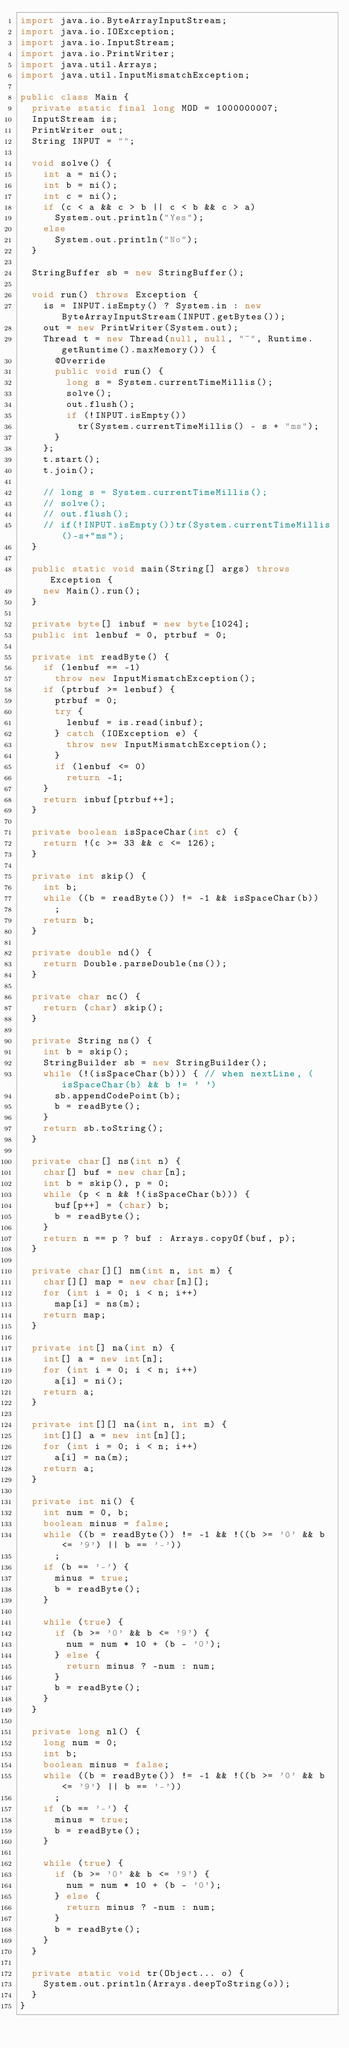Convert code to text. <code><loc_0><loc_0><loc_500><loc_500><_Java_>import java.io.ByteArrayInputStream;
import java.io.IOException;
import java.io.InputStream;
import java.io.PrintWriter;
import java.util.Arrays;
import java.util.InputMismatchException;

public class Main {
	private static final long MOD = 1000000007;
	InputStream is;
	PrintWriter out;
	String INPUT = "";

	void solve() {
		int a = ni();
		int b = ni();
		int c = ni();
		if (c < a && c > b || c < b && c > a)
			System.out.println("Yes");
		else
			System.out.println("No");
	}

	StringBuffer sb = new StringBuffer();

	void run() throws Exception {
		is = INPUT.isEmpty() ? System.in : new ByteArrayInputStream(INPUT.getBytes());
		out = new PrintWriter(System.out);
		Thread t = new Thread(null, null, "~", Runtime.getRuntime().maxMemory()) {
			@Override
			public void run() {
				long s = System.currentTimeMillis();
				solve();
				out.flush();
				if (!INPUT.isEmpty())
					tr(System.currentTimeMillis() - s + "ms");
			}
		};
		t.start();
		t.join();

		// long s = System.currentTimeMillis();
		// solve();
		// out.flush();
		// if(!INPUT.isEmpty())tr(System.currentTimeMillis()-s+"ms");
	}

	public static void main(String[] args) throws Exception {
		new Main().run();
	}

	private byte[] inbuf = new byte[1024];
	public int lenbuf = 0, ptrbuf = 0;

	private int readByte() {
		if (lenbuf == -1)
			throw new InputMismatchException();
		if (ptrbuf >= lenbuf) {
			ptrbuf = 0;
			try {
				lenbuf = is.read(inbuf);
			} catch (IOException e) {
				throw new InputMismatchException();
			}
			if (lenbuf <= 0)
				return -1;
		}
		return inbuf[ptrbuf++];
	}

	private boolean isSpaceChar(int c) {
		return !(c >= 33 && c <= 126);
	}

	private int skip() {
		int b;
		while ((b = readByte()) != -1 && isSpaceChar(b))
			;
		return b;
	}

	private double nd() {
		return Double.parseDouble(ns());
	}

	private char nc() {
		return (char) skip();
	}

	private String ns() {
		int b = skip();
		StringBuilder sb = new StringBuilder();
		while (!(isSpaceChar(b))) { // when nextLine, (isSpaceChar(b) && b != ' ')
			sb.appendCodePoint(b);
			b = readByte();
		}
		return sb.toString();
	}

	private char[] ns(int n) {
		char[] buf = new char[n];
		int b = skip(), p = 0;
		while (p < n && !(isSpaceChar(b))) {
			buf[p++] = (char) b;
			b = readByte();
		}
		return n == p ? buf : Arrays.copyOf(buf, p);
	}

	private char[][] nm(int n, int m) {
		char[][] map = new char[n][];
		for (int i = 0; i < n; i++)
			map[i] = ns(m);
		return map;
	}

	private int[] na(int n) {
		int[] a = new int[n];
		for (int i = 0; i < n; i++)
			a[i] = ni();
		return a;
	}

	private int[][] na(int n, int m) {
		int[][] a = new int[n][];
		for (int i = 0; i < n; i++)
			a[i] = na(m);
		return a;
	}

	private int ni() {
		int num = 0, b;
		boolean minus = false;
		while ((b = readByte()) != -1 && !((b >= '0' && b <= '9') || b == '-'))
			;
		if (b == '-') {
			minus = true;
			b = readByte();
		}

		while (true) {
			if (b >= '0' && b <= '9') {
				num = num * 10 + (b - '0');
			} else {
				return minus ? -num : num;
			}
			b = readByte();
		}
	}

	private long nl() {
		long num = 0;
		int b;
		boolean minus = false;
		while ((b = readByte()) != -1 && !((b >= '0' && b <= '9') || b == '-'))
			;
		if (b == '-') {
			minus = true;
			b = readByte();
		}

		while (true) {
			if (b >= '0' && b <= '9') {
				num = num * 10 + (b - '0');
			} else {
				return minus ? -num : num;
			}
			b = readByte();
		}
	}

	private static void tr(Object... o) {
		System.out.println(Arrays.deepToString(o));
	}
}</code> 